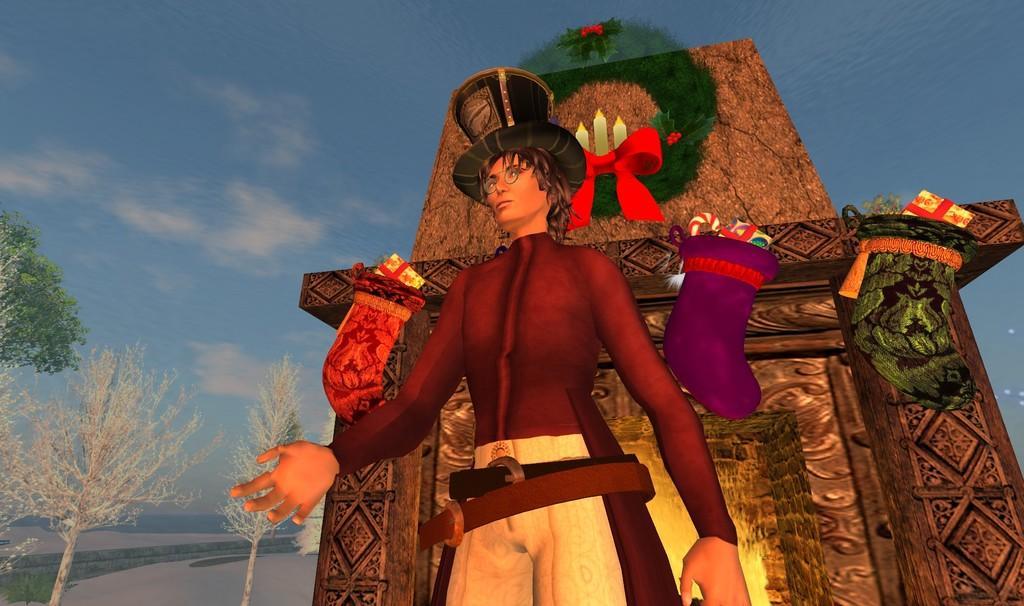Describe this image in one or two sentences. In this picture I can see a person in front who is wearing a hat on head and in the background I see the trees and I see the fire place on which I see socks and a garland on it and I see the sky. 